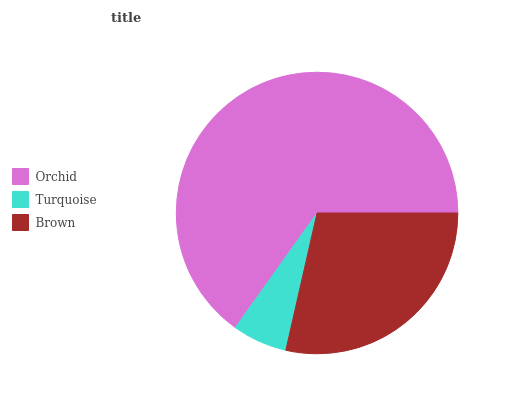Is Turquoise the minimum?
Answer yes or no. Yes. Is Orchid the maximum?
Answer yes or no. Yes. Is Brown the minimum?
Answer yes or no. No. Is Brown the maximum?
Answer yes or no. No. Is Brown greater than Turquoise?
Answer yes or no. Yes. Is Turquoise less than Brown?
Answer yes or no. Yes. Is Turquoise greater than Brown?
Answer yes or no. No. Is Brown less than Turquoise?
Answer yes or no. No. Is Brown the high median?
Answer yes or no. Yes. Is Brown the low median?
Answer yes or no. Yes. Is Orchid the high median?
Answer yes or no. No. Is Turquoise the low median?
Answer yes or no. No. 